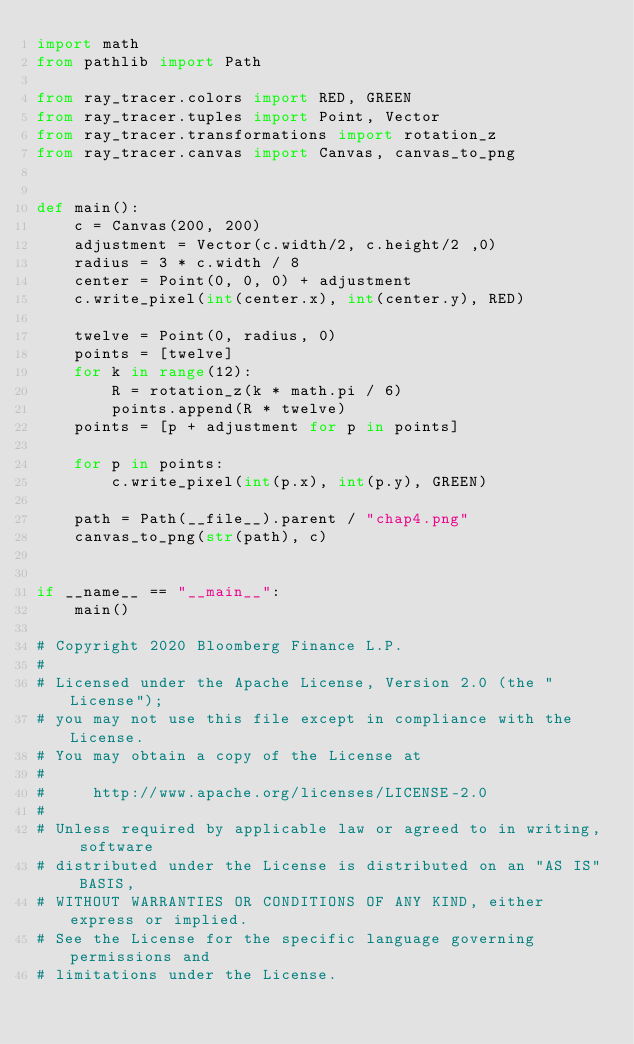<code> <loc_0><loc_0><loc_500><loc_500><_Python_>import math
from pathlib import Path

from ray_tracer.colors import RED, GREEN
from ray_tracer.tuples import Point, Vector
from ray_tracer.transformations import rotation_z
from ray_tracer.canvas import Canvas, canvas_to_png


def main():
    c = Canvas(200, 200)
    adjustment = Vector(c.width/2, c.height/2 ,0)
    radius = 3 * c.width / 8
    center = Point(0, 0, 0) + adjustment
    c.write_pixel(int(center.x), int(center.y), RED)

    twelve = Point(0, radius, 0)
    points = [twelve]
    for k in range(12):
        R = rotation_z(k * math.pi / 6)
        points.append(R * twelve)
    points = [p + adjustment for p in points]

    for p in points:
        c.write_pixel(int(p.x), int(p.y), GREEN)

    path = Path(__file__).parent / "chap4.png"
    canvas_to_png(str(path), c)


if __name__ == "__main__":
    main()

# Copyright 2020 Bloomberg Finance L.P.
#
# Licensed under the Apache License, Version 2.0 (the "License");
# you may not use this file except in compliance with the License.
# You may obtain a copy of the License at
#
#     http://www.apache.org/licenses/LICENSE-2.0
#
# Unless required by applicable law or agreed to in writing, software
# distributed under the License is distributed on an "AS IS" BASIS,
# WITHOUT WARRANTIES OR CONDITIONS OF ANY KIND, either express or implied.
# See the License for the specific language governing permissions and
# limitations under the License.
</code> 